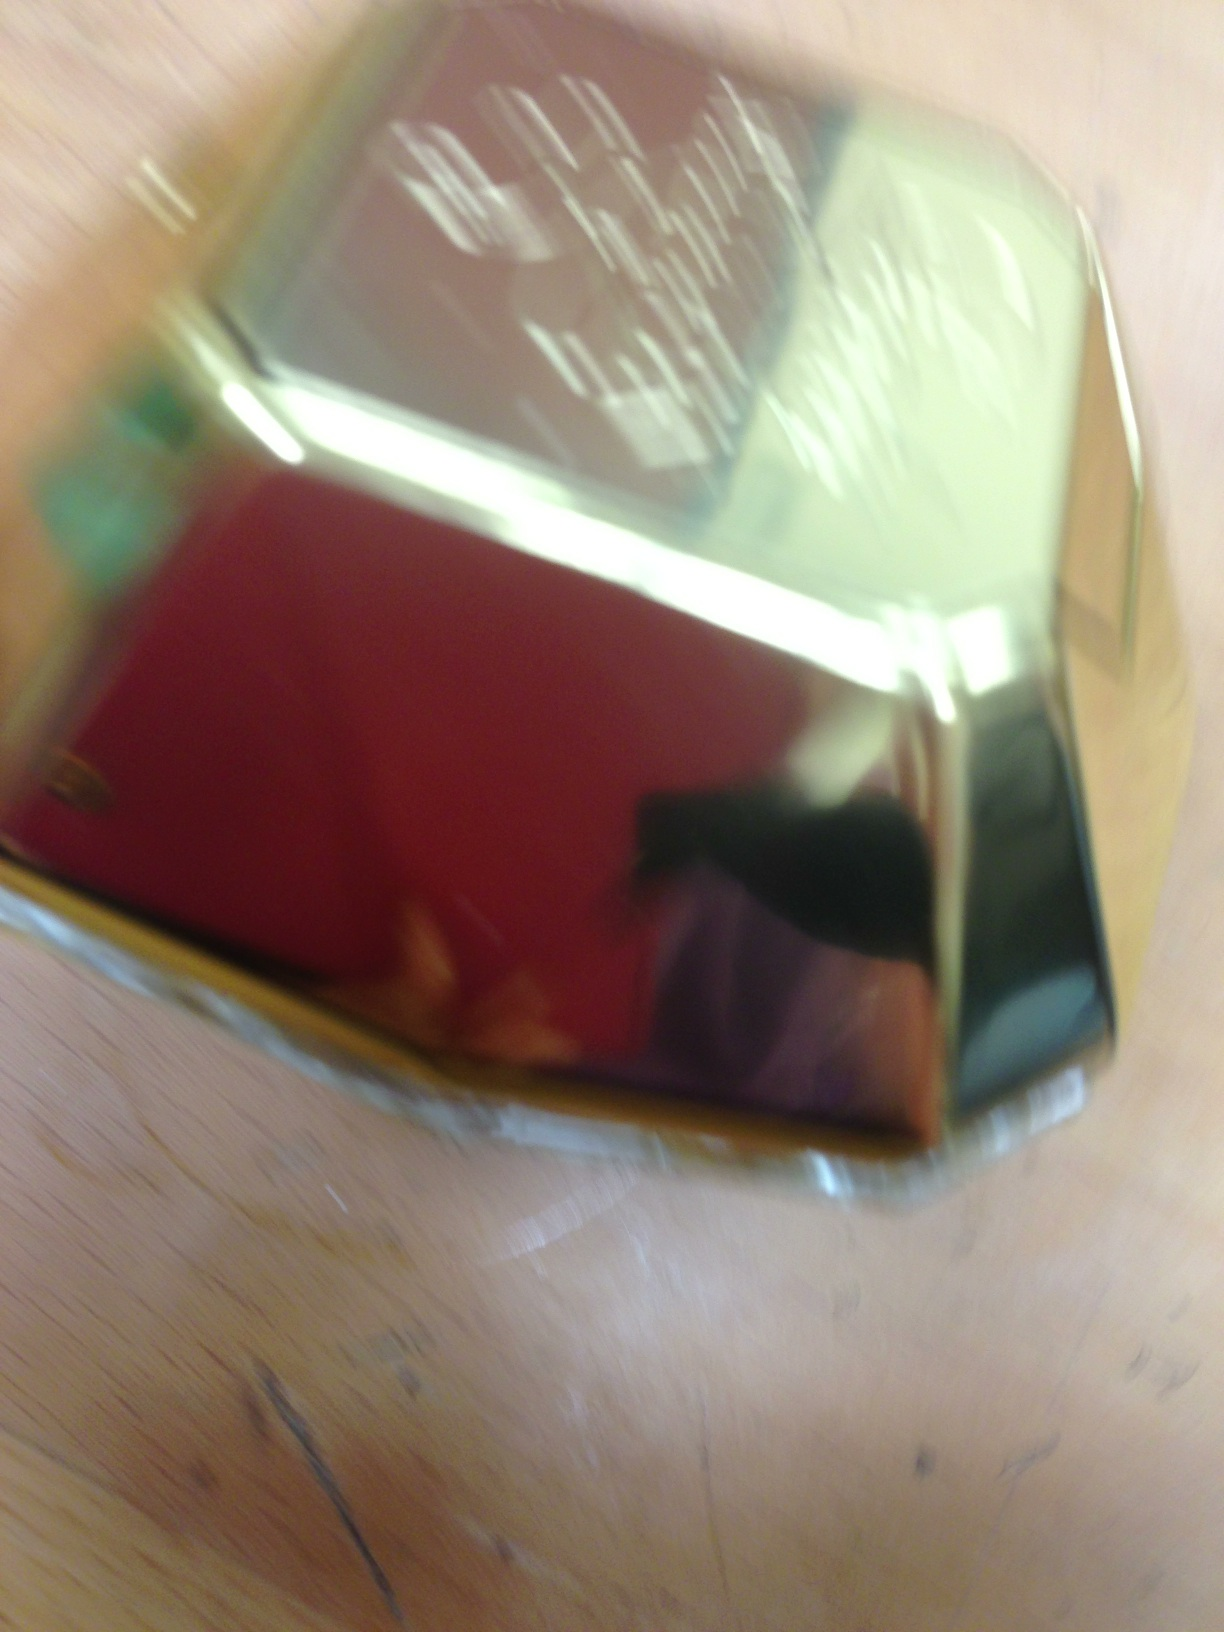If this perfume bottle could talk, what would it say about its fragrance? Ah, if I could speak, I'd tell tales of enchanting floral notes entangled with hints of exotic spices. My aura is designed to captivate, leaving a trail of mystery and allure wherever you go. What kind of occasions would my fragrance be perfect for? I am perfect for elegant evenings and sophisticated gatherings, where my scent can mingle with the air and mesmerize those around you. I'm also a fantastic choice for intimate dinners and special celebrations, adding a touch of allure to every moment. 